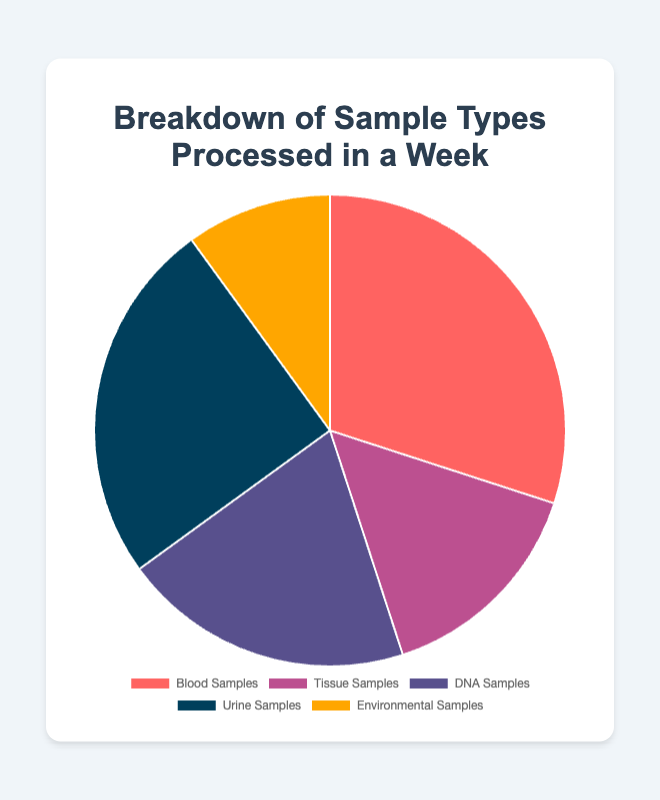What sample type has the highest count? The pie chart shows the breakdown of sample types processed in a week, with Blood Samples having the largest segment. Referring to the labels, Blood Samples have the highest count at 150.
Answer: Blood Samples Which sample type has the lowest count? By looking at the pie chart, the smallest segment represents the sample type with the lowest count. The Environmental Samples segment is the smallest, which has a count of 50.
Answer: Environmental Samples What's the total number of samples processed in a week? To find the total number of samples processed, sum up the counts of all sample types: 150 (Blood) + 75 (Tissue) + 100 (DNA) + 125 (Urine) + 50 (Environmental) = 500.
Answer: 500 How many more Blood Samples were processed compared to Tissue Samples? Subtract the count of Tissue Samples from the count of Blood Samples: 150 (Blood) - 75 (Tissue) = 75.
Answer: 75 Which sample type has a count exactly in the middle when the counts are ordered from lowest to highest? Ordering the counts from lowest to highest: 50 (Environmental), 75 (Tissue), 100 (DNA), 125 (Urine), 150 (Blood). The middle count is 100, corresponding to DNA Samples.
Answer: DNA Samples What percentages of the total do Urine Samples and DNA Samples represent together? First, sum the counts of Urine Samples and DNA Samples: 125 + 100 = 225. Then, divide by the total number of samples and multiply by 100 to find the percentage: (225/500) * 100 = 45%.
Answer: 45% If Environmental and Tissue Samples are combined into a single category, which two original categories (before combining) would this new group be larger than? Combining Environmental (50) and Tissue (75) makes: 50 + 75 = 125. This combined group is equal to Urine Samples (125) and larger than Environmental (50) and Tissue (75) individually. Therefore, the combined group is larger than the original Environmental and Tissue categories.
Answer: Environmental and Tissue What is the approximate percentage of Blood Samples in the total number of samples processed? Divide the count of Blood Samples by the total number of samples and multiply by 100 to find the percentage: (150/500) * 100 ≈ 30%.
Answer: 30% Compare the counts of DNA and Urine Samples. Which is greater, and by how much? Subtract the count of DNA Samples from the count of Urine Samples: 125 (Urine) - 100 (DNA) = 25. Urine Samples are greater by 25.
Answer: Urine Samples by 25 What portion of the pie chart is represented by Tissue Samples in terms of quarters? The total represents a whole pie (4/4). Tissue Samples make up 75/500 of the total count. Convert this fraction to part of the pie: (75/500) = 3/20. Approximating, 3/20 is close to 1/6th of the pie, which is less than a quarter.
Answer: Less than a quarter 